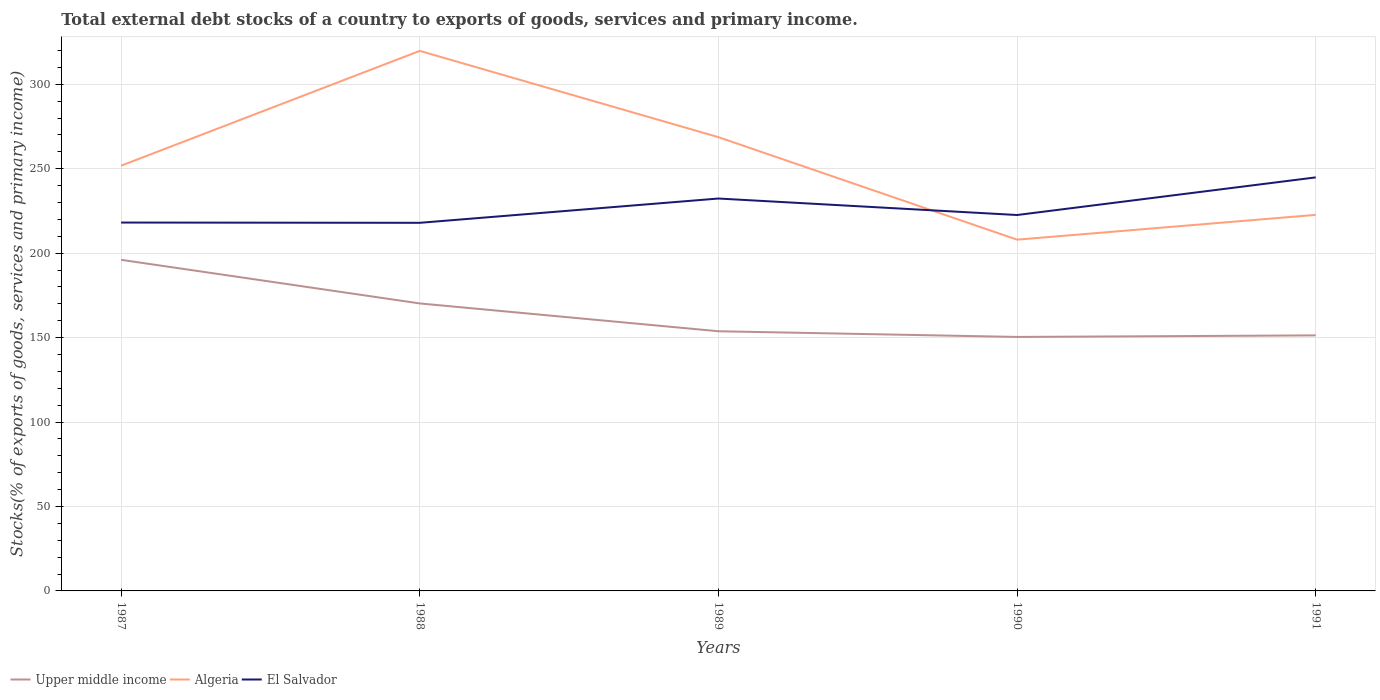Does the line corresponding to Upper middle income intersect with the line corresponding to Algeria?
Provide a succinct answer. No. Across all years, what is the maximum total debt stocks in El Salvador?
Provide a short and direct response. 217.98. In which year was the total debt stocks in Upper middle income maximum?
Ensure brevity in your answer.  1990. What is the total total debt stocks in El Salvador in the graph?
Ensure brevity in your answer.  9.76. What is the difference between the highest and the second highest total debt stocks in Algeria?
Your answer should be very brief. 111.79. How many lines are there?
Your answer should be compact. 3. How many years are there in the graph?
Provide a short and direct response. 5. What is the difference between two consecutive major ticks on the Y-axis?
Provide a succinct answer. 50. Does the graph contain any zero values?
Provide a short and direct response. No. Where does the legend appear in the graph?
Provide a short and direct response. Bottom left. How are the legend labels stacked?
Ensure brevity in your answer.  Horizontal. What is the title of the graph?
Your response must be concise. Total external debt stocks of a country to exports of goods, services and primary income. What is the label or title of the X-axis?
Provide a short and direct response. Years. What is the label or title of the Y-axis?
Give a very brief answer. Stocks(% of exports of goods, services and primary income). What is the Stocks(% of exports of goods, services and primary income) of Upper middle income in 1987?
Provide a short and direct response. 196.06. What is the Stocks(% of exports of goods, services and primary income) of Algeria in 1987?
Make the answer very short. 251.82. What is the Stocks(% of exports of goods, services and primary income) in El Salvador in 1987?
Offer a terse response. 218.15. What is the Stocks(% of exports of goods, services and primary income) of Upper middle income in 1988?
Your response must be concise. 170.24. What is the Stocks(% of exports of goods, services and primary income) in Algeria in 1988?
Provide a succinct answer. 319.8. What is the Stocks(% of exports of goods, services and primary income) of El Salvador in 1988?
Offer a terse response. 217.98. What is the Stocks(% of exports of goods, services and primary income) of Upper middle income in 1989?
Your response must be concise. 153.77. What is the Stocks(% of exports of goods, services and primary income) in Algeria in 1989?
Your response must be concise. 268.7. What is the Stocks(% of exports of goods, services and primary income) in El Salvador in 1989?
Your answer should be compact. 232.37. What is the Stocks(% of exports of goods, services and primary income) in Upper middle income in 1990?
Provide a short and direct response. 150.4. What is the Stocks(% of exports of goods, services and primary income) of Algeria in 1990?
Provide a succinct answer. 208.01. What is the Stocks(% of exports of goods, services and primary income) of El Salvador in 1990?
Keep it short and to the point. 222.6. What is the Stocks(% of exports of goods, services and primary income) in Upper middle income in 1991?
Ensure brevity in your answer.  151.33. What is the Stocks(% of exports of goods, services and primary income) of Algeria in 1991?
Your response must be concise. 222.69. What is the Stocks(% of exports of goods, services and primary income) of El Salvador in 1991?
Your response must be concise. 244.89. Across all years, what is the maximum Stocks(% of exports of goods, services and primary income) in Upper middle income?
Provide a succinct answer. 196.06. Across all years, what is the maximum Stocks(% of exports of goods, services and primary income) in Algeria?
Your answer should be compact. 319.8. Across all years, what is the maximum Stocks(% of exports of goods, services and primary income) in El Salvador?
Your answer should be very brief. 244.89. Across all years, what is the minimum Stocks(% of exports of goods, services and primary income) of Upper middle income?
Provide a short and direct response. 150.4. Across all years, what is the minimum Stocks(% of exports of goods, services and primary income) in Algeria?
Your answer should be compact. 208.01. Across all years, what is the minimum Stocks(% of exports of goods, services and primary income) in El Salvador?
Ensure brevity in your answer.  217.98. What is the total Stocks(% of exports of goods, services and primary income) in Upper middle income in the graph?
Offer a very short reply. 821.81. What is the total Stocks(% of exports of goods, services and primary income) of Algeria in the graph?
Your answer should be compact. 1271.02. What is the total Stocks(% of exports of goods, services and primary income) in El Salvador in the graph?
Ensure brevity in your answer.  1135.99. What is the difference between the Stocks(% of exports of goods, services and primary income) in Upper middle income in 1987 and that in 1988?
Your response must be concise. 25.82. What is the difference between the Stocks(% of exports of goods, services and primary income) in Algeria in 1987 and that in 1988?
Your answer should be compact. -67.98. What is the difference between the Stocks(% of exports of goods, services and primary income) in El Salvador in 1987 and that in 1988?
Give a very brief answer. 0.16. What is the difference between the Stocks(% of exports of goods, services and primary income) in Upper middle income in 1987 and that in 1989?
Offer a terse response. 42.29. What is the difference between the Stocks(% of exports of goods, services and primary income) of Algeria in 1987 and that in 1989?
Your response must be concise. -16.89. What is the difference between the Stocks(% of exports of goods, services and primary income) of El Salvador in 1987 and that in 1989?
Your answer should be very brief. -14.22. What is the difference between the Stocks(% of exports of goods, services and primary income) of Upper middle income in 1987 and that in 1990?
Your answer should be very brief. 45.66. What is the difference between the Stocks(% of exports of goods, services and primary income) of Algeria in 1987 and that in 1990?
Offer a very short reply. 43.81. What is the difference between the Stocks(% of exports of goods, services and primary income) of El Salvador in 1987 and that in 1990?
Provide a succinct answer. -4.46. What is the difference between the Stocks(% of exports of goods, services and primary income) in Upper middle income in 1987 and that in 1991?
Ensure brevity in your answer.  44.73. What is the difference between the Stocks(% of exports of goods, services and primary income) of Algeria in 1987 and that in 1991?
Offer a terse response. 29.12. What is the difference between the Stocks(% of exports of goods, services and primary income) in El Salvador in 1987 and that in 1991?
Provide a short and direct response. -26.74. What is the difference between the Stocks(% of exports of goods, services and primary income) in Upper middle income in 1988 and that in 1989?
Your answer should be compact. 16.47. What is the difference between the Stocks(% of exports of goods, services and primary income) of Algeria in 1988 and that in 1989?
Your response must be concise. 51.1. What is the difference between the Stocks(% of exports of goods, services and primary income) in El Salvador in 1988 and that in 1989?
Provide a short and direct response. -14.39. What is the difference between the Stocks(% of exports of goods, services and primary income) in Upper middle income in 1988 and that in 1990?
Your answer should be compact. 19.84. What is the difference between the Stocks(% of exports of goods, services and primary income) in Algeria in 1988 and that in 1990?
Give a very brief answer. 111.79. What is the difference between the Stocks(% of exports of goods, services and primary income) in El Salvador in 1988 and that in 1990?
Provide a short and direct response. -4.62. What is the difference between the Stocks(% of exports of goods, services and primary income) of Upper middle income in 1988 and that in 1991?
Keep it short and to the point. 18.91. What is the difference between the Stocks(% of exports of goods, services and primary income) in Algeria in 1988 and that in 1991?
Your answer should be very brief. 97.11. What is the difference between the Stocks(% of exports of goods, services and primary income) in El Salvador in 1988 and that in 1991?
Keep it short and to the point. -26.91. What is the difference between the Stocks(% of exports of goods, services and primary income) of Upper middle income in 1989 and that in 1990?
Ensure brevity in your answer.  3.37. What is the difference between the Stocks(% of exports of goods, services and primary income) in Algeria in 1989 and that in 1990?
Offer a terse response. 60.69. What is the difference between the Stocks(% of exports of goods, services and primary income) in El Salvador in 1989 and that in 1990?
Provide a succinct answer. 9.76. What is the difference between the Stocks(% of exports of goods, services and primary income) of Upper middle income in 1989 and that in 1991?
Keep it short and to the point. 2.44. What is the difference between the Stocks(% of exports of goods, services and primary income) in Algeria in 1989 and that in 1991?
Provide a succinct answer. 46.01. What is the difference between the Stocks(% of exports of goods, services and primary income) in El Salvador in 1989 and that in 1991?
Provide a succinct answer. -12.52. What is the difference between the Stocks(% of exports of goods, services and primary income) of Upper middle income in 1990 and that in 1991?
Offer a terse response. -0.93. What is the difference between the Stocks(% of exports of goods, services and primary income) of Algeria in 1990 and that in 1991?
Provide a short and direct response. -14.68. What is the difference between the Stocks(% of exports of goods, services and primary income) in El Salvador in 1990 and that in 1991?
Offer a terse response. -22.29. What is the difference between the Stocks(% of exports of goods, services and primary income) in Upper middle income in 1987 and the Stocks(% of exports of goods, services and primary income) in Algeria in 1988?
Ensure brevity in your answer.  -123.74. What is the difference between the Stocks(% of exports of goods, services and primary income) in Upper middle income in 1987 and the Stocks(% of exports of goods, services and primary income) in El Salvador in 1988?
Provide a short and direct response. -21.92. What is the difference between the Stocks(% of exports of goods, services and primary income) of Algeria in 1987 and the Stocks(% of exports of goods, services and primary income) of El Salvador in 1988?
Provide a succinct answer. 33.83. What is the difference between the Stocks(% of exports of goods, services and primary income) in Upper middle income in 1987 and the Stocks(% of exports of goods, services and primary income) in Algeria in 1989?
Ensure brevity in your answer.  -72.64. What is the difference between the Stocks(% of exports of goods, services and primary income) in Upper middle income in 1987 and the Stocks(% of exports of goods, services and primary income) in El Salvador in 1989?
Keep it short and to the point. -36.3. What is the difference between the Stocks(% of exports of goods, services and primary income) in Algeria in 1987 and the Stocks(% of exports of goods, services and primary income) in El Salvador in 1989?
Ensure brevity in your answer.  19.45. What is the difference between the Stocks(% of exports of goods, services and primary income) in Upper middle income in 1987 and the Stocks(% of exports of goods, services and primary income) in Algeria in 1990?
Provide a short and direct response. -11.95. What is the difference between the Stocks(% of exports of goods, services and primary income) of Upper middle income in 1987 and the Stocks(% of exports of goods, services and primary income) of El Salvador in 1990?
Keep it short and to the point. -26.54. What is the difference between the Stocks(% of exports of goods, services and primary income) of Algeria in 1987 and the Stocks(% of exports of goods, services and primary income) of El Salvador in 1990?
Offer a terse response. 29.21. What is the difference between the Stocks(% of exports of goods, services and primary income) of Upper middle income in 1987 and the Stocks(% of exports of goods, services and primary income) of Algeria in 1991?
Make the answer very short. -26.63. What is the difference between the Stocks(% of exports of goods, services and primary income) in Upper middle income in 1987 and the Stocks(% of exports of goods, services and primary income) in El Salvador in 1991?
Give a very brief answer. -48.83. What is the difference between the Stocks(% of exports of goods, services and primary income) in Algeria in 1987 and the Stocks(% of exports of goods, services and primary income) in El Salvador in 1991?
Provide a short and direct response. 6.93. What is the difference between the Stocks(% of exports of goods, services and primary income) in Upper middle income in 1988 and the Stocks(% of exports of goods, services and primary income) in Algeria in 1989?
Ensure brevity in your answer.  -98.47. What is the difference between the Stocks(% of exports of goods, services and primary income) of Upper middle income in 1988 and the Stocks(% of exports of goods, services and primary income) of El Salvador in 1989?
Offer a very short reply. -62.13. What is the difference between the Stocks(% of exports of goods, services and primary income) in Algeria in 1988 and the Stocks(% of exports of goods, services and primary income) in El Salvador in 1989?
Provide a succinct answer. 87.43. What is the difference between the Stocks(% of exports of goods, services and primary income) in Upper middle income in 1988 and the Stocks(% of exports of goods, services and primary income) in Algeria in 1990?
Offer a terse response. -37.77. What is the difference between the Stocks(% of exports of goods, services and primary income) in Upper middle income in 1988 and the Stocks(% of exports of goods, services and primary income) in El Salvador in 1990?
Offer a terse response. -52.36. What is the difference between the Stocks(% of exports of goods, services and primary income) in Algeria in 1988 and the Stocks(% of exports of goods, services and primary income) in El Salvador in 1990?
Provide a short and direct response. 97.2. What is the difference between the Stocks(% of exports of goods, services and primary income) in Upper middle income in 1988 and the Stocks(% of exports of goods, services and primary income) in Algeria in 1991?
Your answer should be very brief. -52.45. What is the difference between the Stocks(% of exports of goods, services and primary income) in Upper middle income in 1988 and the Stocks(% of exports of goods, services and primary income) in El Salvador in 1991?
Offer a terse response. -74.65. What is the difference between the Stocks(% of exports of goods, services and primary income) in Algeria in 1988 and the Stocks(% of exports of goods, services and primary income) in El Salvador in 1991?
Provide a short and direct response. 74.91. What is the difference between the Stocks(% of exports of goods, services and primary income) of Upper middle income in 1989 and the Stocks(% of exports of goods, services and primary income) of Algeria in 1990?
Ensure brevity in your answer.  -54.24. What is the difference between the Stocks(% of exports of goods, services and primary income) of Upper middle income in 1989 and the Stocks(% of exports of goods, services and primary income) of El Salvador in 1990?
Provide a short and direct response. -68.83. What is the difference between the Stocks(% of exports of goods, services and primary income) in Algeria in 1989 and the Stocks(% of exports of goods, services and primary income) in El Salvador in 1990?
Your answer should be compact. 46.1. What is the difference between the Stocks(% of exports of goods, services and primary income) in Upper middle income in 1989 and the Stocks(% of exports of goods, services and primary income) in Algeria in 1991?
Your answer should be compact. -68.92. What is the difference between the Stocks(% of exports of goods, services and primary income) of Upper middle income in 1989 and the Stocks(% of exports of goods, services and primary income) of El Salvador in 1991?
Your answer should be very brief. -91.12. What is the difference between the Stocks(% of exports of goods, services and primary income) of Algeria in 1989 and the Stocks(% of exports of goods, services and primary income) of El Salvador in 1991?
Give a very brief answer. 23.81. What is the difference between the Stocks(% of exports of goods, services and primary income) of Upper middle income in 1990 and the Stocks(% of exports of goods, services and primary income) of Algeria in 1991?
Your response must be concise. -72.29. What is the difference between the Stocks(% of exports of goods, services and primary income) in Upper middle income in 1990 and the Stocks(% of exports of goods, services and primary income) in El Salvador in 1991?
Your answer should be compact. -94.49. What is the difference between the Stocks(% of exports of goods, services and primary income) of Algeria in 1990 and the Stocks(% of exports of goods, services and primary income) of El Salvador in 1991?
Ensure brevity in your answer.  -36.88. What is the average Stocks(% of exports of goods, services and primary income) in Upper middle income per year?
Your response must be concise. 164.36. What is the average Stocks(% of exports of goods, services and primary income) of Algeria per year?
Provide a short and direct response. 254.2. What is the average Stocks(% of exports of goods, services and primary income) of El Salvador per year?
Provide a succinct answer. 227.2. In the year 1987, what is the difference between the Stocks(% of exports of goods, services and primary income) of Upper middle income and Stocks(% of exports of goods, services and primary income) of Algeria?
Offer a terse response. -55.75. In the year 1987, what is the difference between the Stocks(% of exports of goods, services and primary income) of Upper middle income and Stocks(% of exports of goods, services and primary income) of El Salvador?
Your answer should be compact. -22.08. In the year 1987, what is the difference between the Stocks(% of exports of goods, services and primary income) in Algeria and Stocks(% of exports of goods, services and primary income) in El Salvador?
Your response must be concise. 33.67. In the year 1988, what is the difference between the Stocks(% of exports of goods, services and primary income) in Upper middle income and Stocks(% of exports of goods, services and primary income) in Algeria?
Provide a short and direct response. -149.56. In the year 1988, what is the difference between the Stocks(% of exports of goods, services and primary income) in Upper middle income and Stocks(% of exports of goods, services and primary income) in El Salvador?
Provide a short and direct response. -47.74. In the year 1988, what is the difference between the Stocks(% of exports of goods, services and primary income) of Algeria and Stocks(% of exports of goods, services and primary income) of El Salvador?
Your answer should be compact. 101.82. In the year 1989, what is the difference between the Stocks(% of exports of goods, services and primary income) in Upper middle income and Stocks(% of exports of goods, services and primary income) in Algeria?
Your answer should be very brief. -114.93. In the year 1989, what is the difference between the Stocks(% of exports of goods, services and primary income) of Upper middle income and Stocks(% of exports of goods, services and primary income) of El Salvador?
Your response must be concise. -78.6. In the year 1989, what is the difference between the Stocks(% of exports of goods, services and primary income) in Algeria and Stocks(% of exports of goods, services and primary income) in El Salvador?
Offer a very short reply. 36.34. In the year 1990, what is the difference between the Stocks(% of exports of goods, services and primary income) in Upper middle income and Stocks(% of exports of goods, services and primary income) in Algeria?
Your answer should be very brief. -57.61. In the year 1990, what is the difference between the Stocks(% of exports of goods, services and primary income) in Upper middle income and Stocks(% of exports of goods, services and primary income) in El Salvador?
Your answer should be compact. -72.2. In the year 1990, what is the difference between the Stocks(% of exports of goods, services and primary income) in Algeria and Stocks(% of exports of goods, services and primary income) in El Salvador?
Your response must be concise. -14.59. In the year 1991, what is the difference between the Stocks(% of exports of goods, services and primary income) in Upper middle income and Stocks(% of exports of goods, services and primary income) in Algeria?
Make the answer very short. -71.36. In the year 1991, what is the difference between the Stocks(% of exports of goods, services and primary income) of Upper middle income and Stocks(% of exports of goods, services and primary income) of El Salvador?
Ensure brevity in your answer.  -93.56. In the year 1991, what is the difference between the Stocks(% of exports of goods, services and primary income) of Algeria and Stocks(% of exports of goods, services and primary income) of El Salvador?
Give a very brief answer. -22.2. What is the ratio of the Stocks(% of exports of goods, services and primary income) of Upper middle income in 1987 to that in 1988?
Make the answer very short. 1.15. What is the ratio of the Stocks(% of exports of goods, services and primary income) of Algeria in 1987 to that in 1988?
Provide a short and direct response. 0.79. What is the ratio of the Stocks(% of exports of goods, services and primary income) in El Salvador in 1987 to that in 1988?
Make the answer very short. 1. What is the ratio of the Stocks(% of exports of goods, services and primary income) in Upper middle income in 1987 to that in 1989?
Make the answer very short. 1.27. What is the ratio of the Stocks(% of exports of goods, services and primary income) in Algeria in 1987 to that in 1989?
Make the answer very short. 0.94. What is the ratio of the Stocks(% of exports of goods, services and primary income) in El Salvador in 1987 to that in 1989?
Provide a short and direct response. 0.94. What is the ratio of the Stocks(% of exports of goods, services and primary income) of Upper middle income in 1987 to that in 1990?
Your response must be concise. 1.3. What is the ratio of the Stocks(% of exports of goods, services and primary income) of Algeria in 1987 to that in 1990?
Provide a short and direct response. 1.21. What is the ratio of the Stocks(% of exports of goods, services and primary income) in El Salvador in 1987 to that in 1990?
Your answer should be compact. 0.98. What is the ratio of the Stocks(% of exports of goods, services and primary income) in Upper middle income in 1987 to that in 1991?
Offer a terse response. 1.3. What is the ratio of the Stocks(% of exports of goods, services and primary income) in Algeria in 1987 to that in 1991?
Keep it short and to the point. 1.13. What is the ratio of the Stocks(% of exports of goods, services and primary income) in El Salvador in 1987 to that in 1991?
Offer a very short reply. 0.89. What is the ratio of the Stocks(% of exports of goods, services and primary income) in Upper middle income in 1988 to that in 1989?
Offer a terse response. 1.11. What is the ratio of the Stocks(% of exports of goods, services and primary income) in Algeria in 1988 to that in 1989?
Ensure brevity in your answer.  1.19. What is the ratio of the Stocks(% of exports of goods, services and primary income) of El Salvador in 1988 to that in 1989?
Your answer should be compact. 0.94. What is the ratio of the Stocks(% of exports of goods, services and primary income) in Upper middle income in 1988 to that in 1990?
Provide a succinct answer. 1.13. What is the ratio of the Stocks(% of exports of goods, services and primary income) in Algeria in 1988 to that in 1990?
Provide a succinct answer. 1.54. What is the ratio of the Stocks(% of exports of goods, services and primary income) of El Salvador in 1988 to that in 1990?
Provide a short and direct response. 0.98. What is the ratio of the Stocks(% of exports of goods, services and primary income) of Upper middle income in 1988 to that in 1991?
Offer a terse response. 1.12. What is the ratio of the Stocks(% of exports of goods, services and primary income) of Algeria in 1988 to that in 1991?
Your response must be concise. 1.44. What is the ratio of the Stocks(% of exports of goods, services and primary income) in El Salvador in 1988 to that in 1991?
Make the answer very short. 0.89. What is the ratio of the Stocks(% of exports of goods, services and primary income) in Upper middle income in 1989 to that in 1990?
Ensure brevity in your answer.  1.02. What is the ratio of the Stocks(% of exports of goods, services and primary income) of Algeria in 1989 to that in 1990?
Your answer should be very brief. 1.29. What is the ratio of the Stocks(% of exports of goods, services and primary income) in El Salvador in 1989 to that in 1990?
Provide a succinct answer. 1.04. What is the ratio of the Stocks(% of exports of goods, services and primary income) of Upper middle income in 1989 to that in 1991?
Your response must be concise. 1.02. What is the ratio of the Stocks(% of exports of goods, services and primary income) in Algeria in 1989 to that in 1991?
Provide a succinct answer. 1.21. What is the ratio of the Stocks(% of exports of goods, services and primary income) of El Salvador in 1989 to that in 1991?
Keep it short and to the point. 0.95. What is the ratio of the Stocks(% of exports of goods, services and primary income) of Algeria in 1990 to that in 1991?
Ensure brevity in your answer.  0.93. What is the ratio of the Stocks(% of exports of goods, services and primary income) in El Salvador in 1990 to that in 1991?
Give a very brief answer. 0.91. What is the difference between the highest and the second highest Stocks(% of exports of goods, services and primary income) in Upper middle income?
Make the answer very short. 25.82. What is the difference between the highest and the second highest Stocks(% of exports of goods, services and primary income) in Algeria?
Give a very brief answer. 51.1. What is the difference between the highest and the second highest Stocks(% of exports of goods, services and primary income) of El Salvador?
Your answer should be very brief. 12.52. What is the difference between the highest and the lowest Stocks(% of exports of goods, services and primary income) of Upper middle income?
Your response must be concise. 45.66. What is the difference between the highest and the lowest Stocks(% of exports of goods, services and primary income) of Algeria?
Give a very brief answer. 111.79. What is the difference between the highest and the lowest Stocks(% of exports of goods, services and primary income) in El Salvador?
Offer a very short reply. 26.91. 